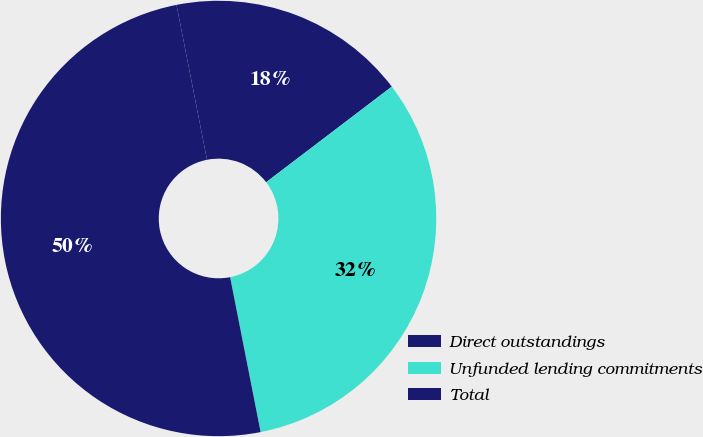Convert chart. <chart><loc_0><loc_0><loc_500><loc_500><pie_chart><fcel>Direct outstandings<fcel>Unfunded lending commitments<fcel>Total<nl><fcel>17.74%<fcel>32.26%<fcel>50.0%<nl></chart> 